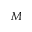Convert formula to latex. <formula><loc_0><loc_0><loc_500><loc_500>M</formula> 